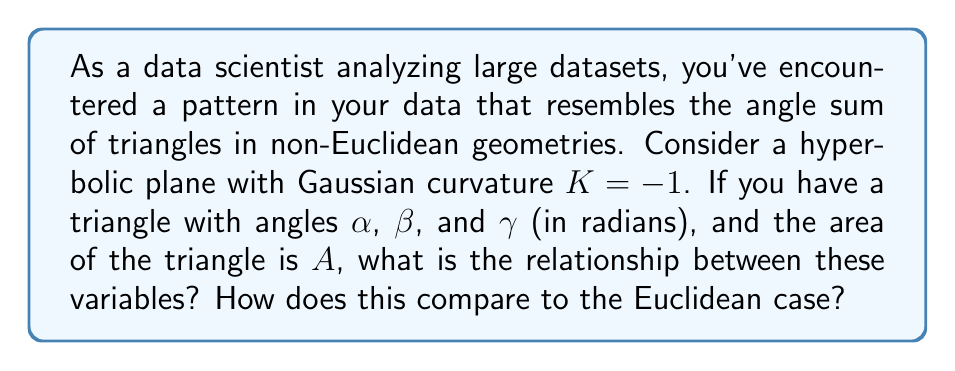Provide a solution to this math problem. Let's approach this step-by-step:

1) In Euclidean geometry, we know that the sum of angles in a triangle is always $\pi$ radians (or 180°). This can be expressed as:

   $$\alpha + \beta + \gamma = \pi$$

2) However, in hyperbolic geometry, this relationship changes. The sum of angles in a hyperbolic triangle is always less than $\pi$.

3) In a hyperbolic plane with constant negative curvature $K$, the relationship between the angles and area of a triangle is given by the Gauss-Bonnet theorem:

   $$\alpha + \beta + \gamma = \pi - |K|A$$

4) In this case, we're given that $K = -1$, so our equation becomes:

   $$\alpha + \beta + \gamma = \pi - A$$

5) This equation tells us that as the area of the triangle increases, the sum of its angles decreases, which is a key difference from Euclidean geometry.

6) Comparing to the Euclidean case:
   - Euclidean: $\alpha + \beta + \gamma = \pi$ (constant, regardless of area)
   - Hyperbolic: $\alpha + \beta + \gamma = \pi - A$ (decreases as area increases)

7) In the context of data analysis, if you're finding patterns in your dataset that resemble this hyperbolic relationship rather than the constant Euclidean sum, it could indicate that your data has some underlying hyperbolic structure or properties.
Answer: $\alpha + \beta + \gamma = \pi - A$ 